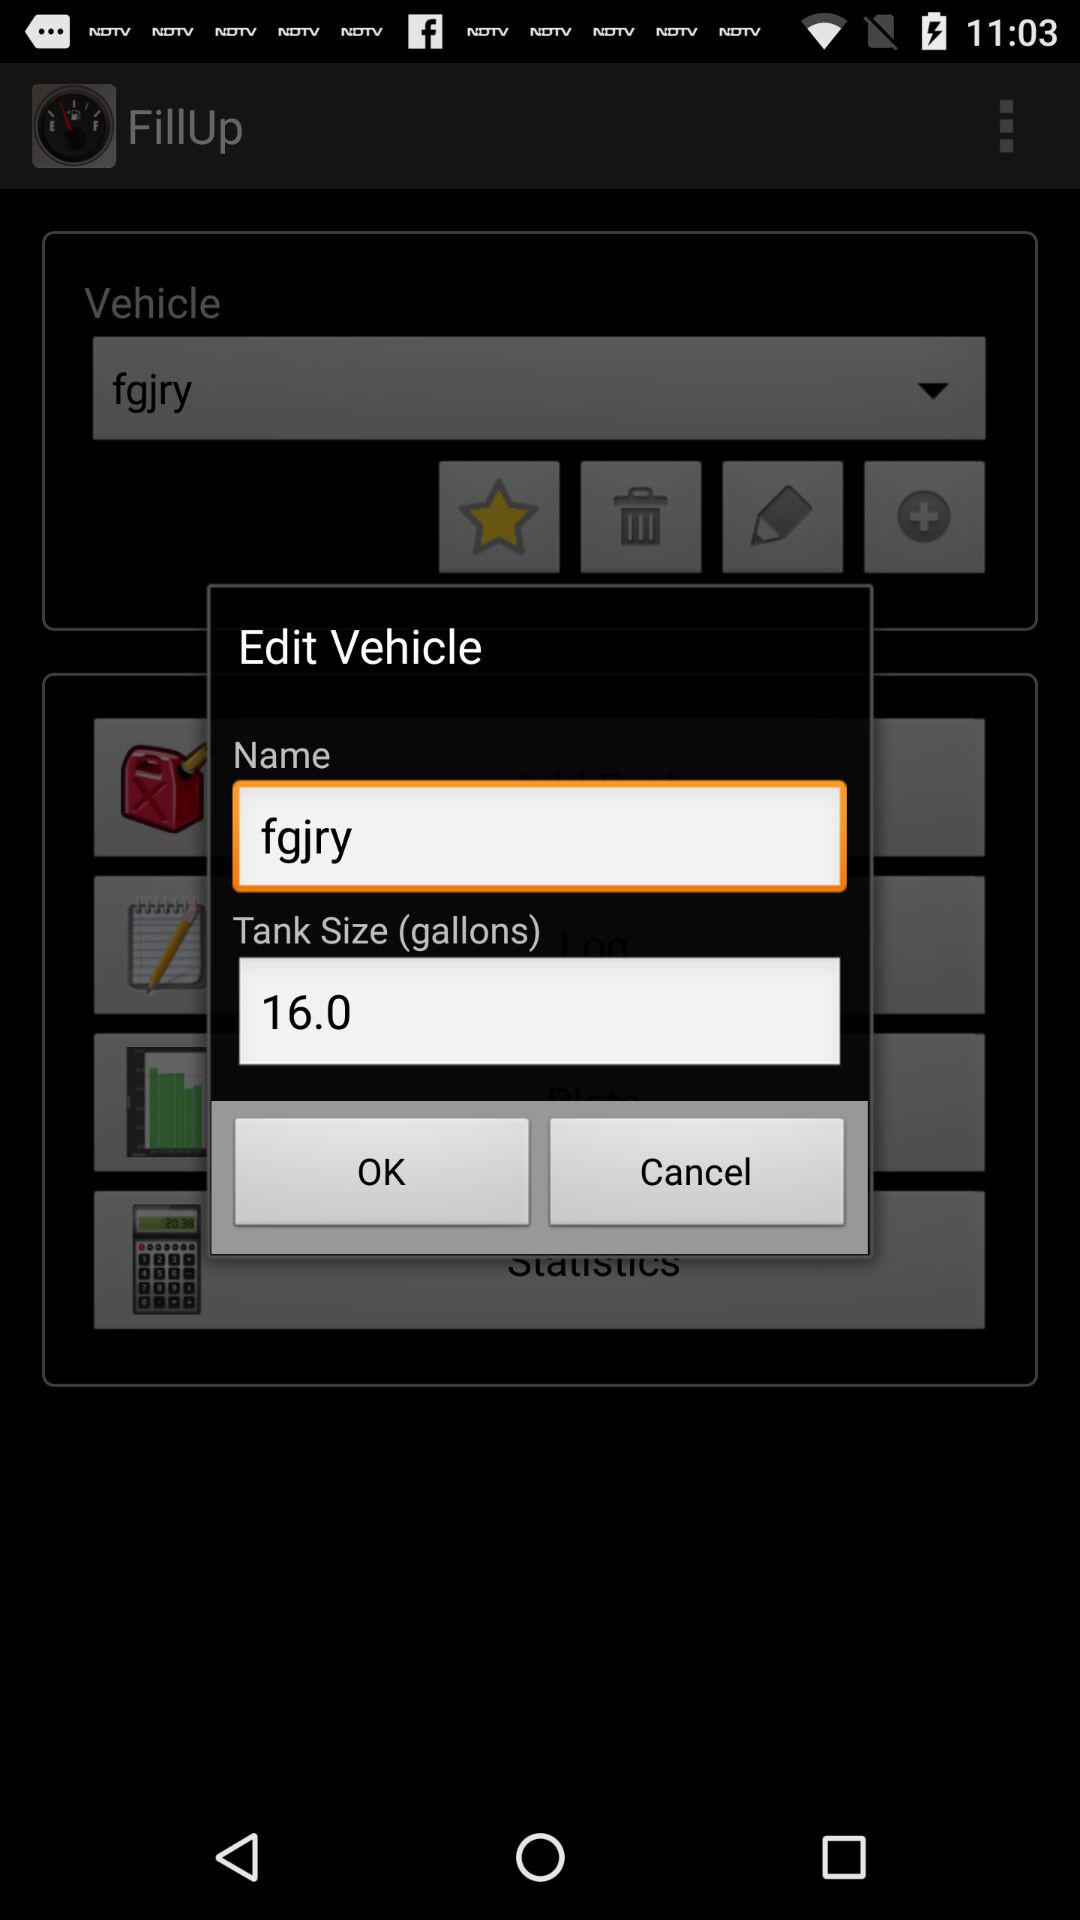How many gallons does the tank hold?
Answer the question using a single word or phrase. 16.0 